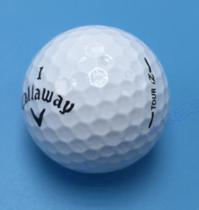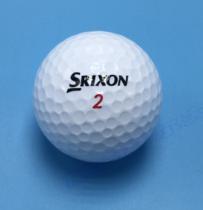The first image is the image on the left, the second image is the image on the right. Given the left and right images, does the statement "There are six white golf balls and at least some of them have T holders under or near them." hold true? Answer yes or no. No. The first image is the image on the left, the second image is the image on the right. Assess this claim about the two images: "there are golf balls in sets of 3". Correct or not? Answer yes or no. No. 